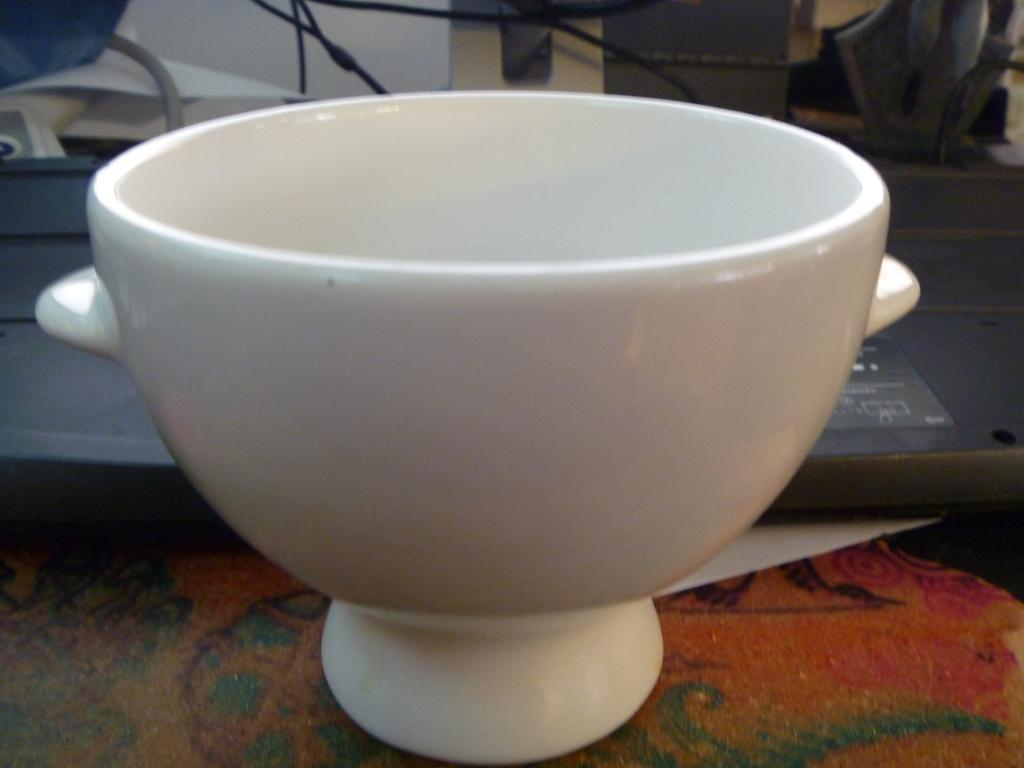What color is the bowl in the image? The bowl in the image is white. Where is the bowl located in the image? The bowl is placed on the floor. Can you describe the background of the image? There are objects in the background of the image. What type of design can be seen on the cactus in the image? There is no cactus present in the image, so it is not possible to answer that question. 